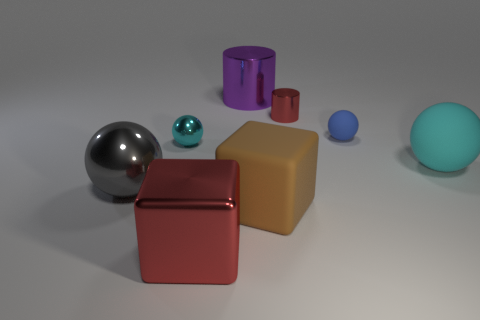Are there more objects that are left of the purple metal cylinder than tiny blue balls that are in front of the cyan metallic ball?
Provide a succinct answer. Yes. There is a tiny sphere that is right of the big rubber block; what color is it?
Make the answer very short. Blue. There is a metal thing on the right side of the big purple thing; is it the same shape as the large thing behind the small rubber object?
Offer a very short reply. Yes. Are there any blue matte objects of the same size as the purple object?
Your response must be concise. No. There is a cyan sphere that is in front of the cyan metallic thing; what is its material?
Provide a short and direct response. Rubber. Are the block to the left of the large rubber cube and the purple thing made of the same material?
Make the answer very short. Yes. Is there a cyan rubber ball?
Keep it short and to the point. Yes. There is a tiny ball that is the same material as the brown object; what color is it?
Offer a terse response. Blue. There is a tiny ball right of the small sphere that is left of the big block on the left side of the large purple shiny thing; what color is it?
Your answer should be very brief. Blue. Is the size of the red cylinder the same as the cyan object that is right of the large red metal block?
Your response must be concise. No. 